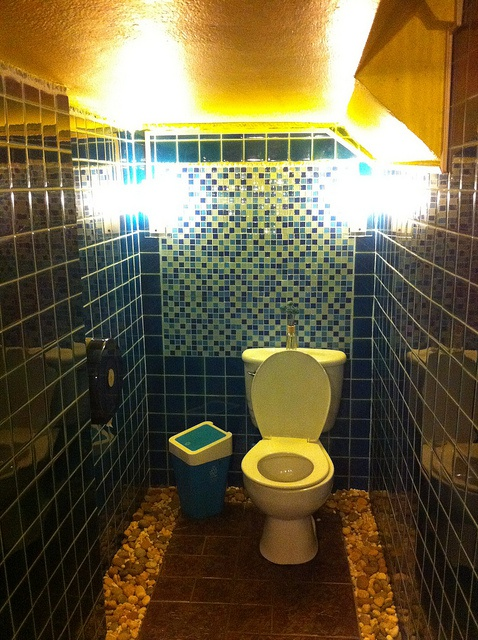Describe the objects in this image and their specific colors. I can see a toilet in maroon and olive tones in this image. 